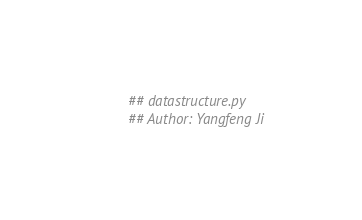Convert code to text. <code><loc_0><loc_0><loc_500><loc_500><_Python_>## datastructure.py
## Author: Yangfeng Ji</code> 